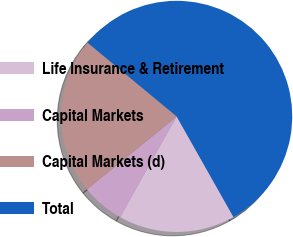<chart> <loc_0><loc_0><loc_500><loc_500><pie_chart><fcel>Life Insurance & Retirement<fcel>Capital Markets<fcel>Capital Markets (d)<fcel>Total<nl><fcel>16.32%<fcel>6.01%<fcel>21.85%<fcel>55.81%<nl></chart> 